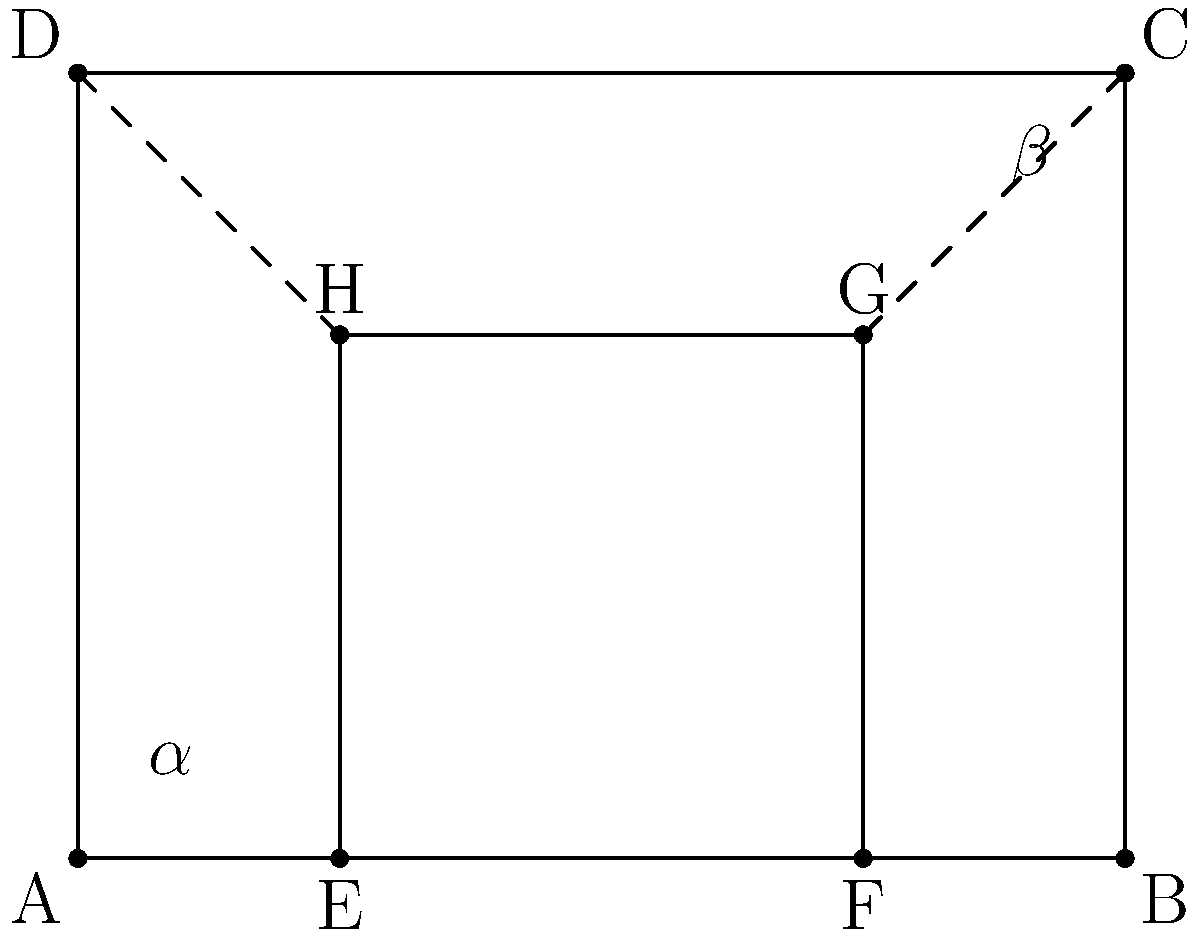In the design of a guitar's sound hole, two rectangular shapes are shown above. If angle $\alpha$ is congruent to angle $\beta$, what can be concluded about the relationship between rectangles ABCD and EFGH? To determine the relationship between rectangles ABCD and EFGH, we need to follow these steps:

1. Recognize that angles $\alpha$ and $\beta$ are corresponding angles formed by the parallel lines AD and EH intersecting with AB and EF respectively.

2. Given that $\alpha$ is congruent to $\beta$, we can conclude that AD is parallel to EH and AB is parallel to EF.

3. In a rectangle, opposite sides are parallel. Therefore, BC is parallel to AD, and DC is parallel to AB.

4. Since AD || EH and DC || FG, we can conclude that EFGH is similar to ABCD.

5. To determine if they are congruent, we need to check if they have the same size and shape.

6. Notice that EF = 1/2 AB and EH = 2/3 AD.

7. The ratio of corresponding sides is constant (2:3), which means EFGH is a scaled version of ABCD.

Therefore, we can conclude that rectangles ABCD and EFGH are similar but not congruent.
Answer: Similar 